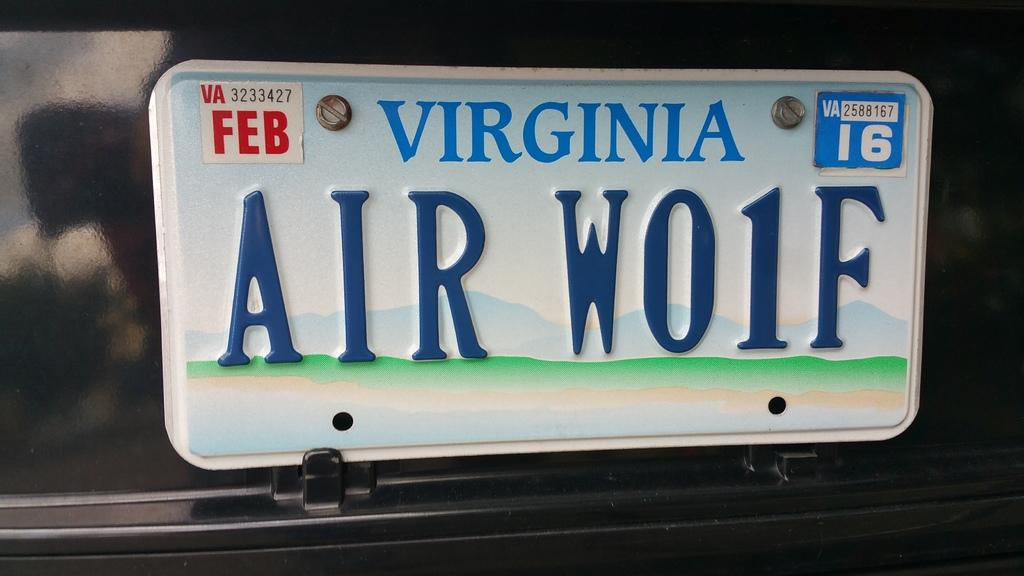<image>
Relay a brief, clear account of the picture shown. a Virginia license plate on a car with air wolf on it 